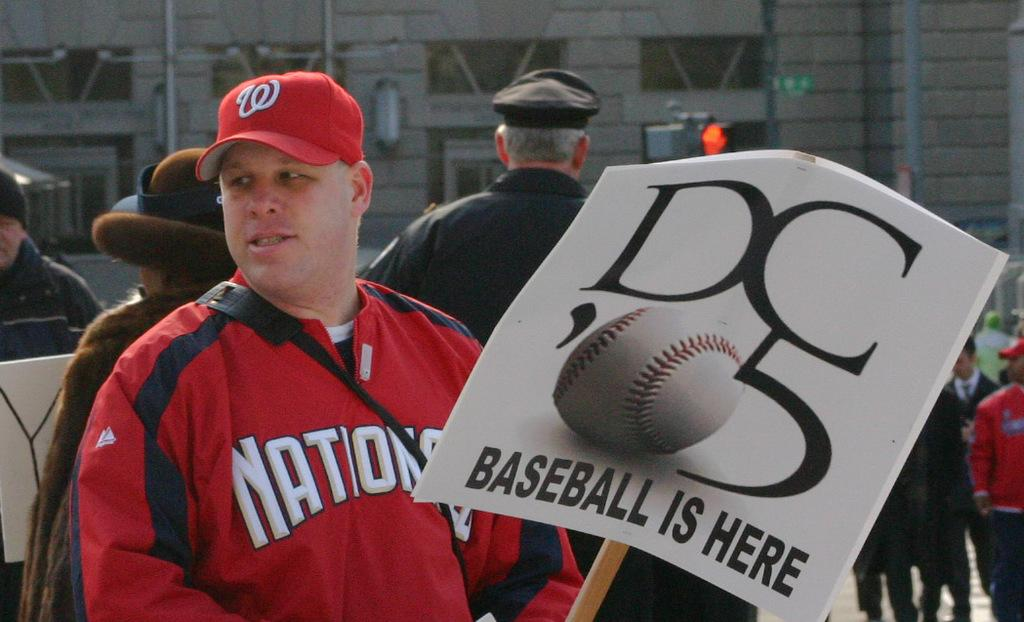<image>
Present a compact description of the photo's key features. A man holds a sign which has the words Baseball is here on it. 